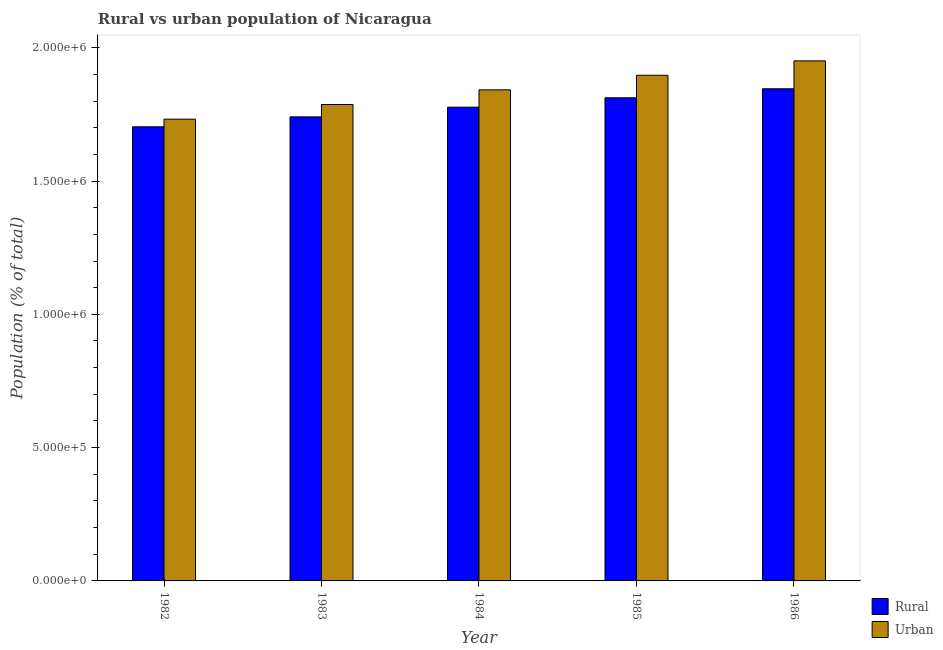Are the number of bars per tick equal to the number of legend labels?
Provide a short and direct response. Yes. How many bars are there on the 3rd tick from the left?
Keep it short and to the point. 2. How many bars are there on the 2nd tick from the right?
Make the answer very short. 2. What is the label of the 1st group of bars from the left?
Give a very brief answer. 1982. What is the urban population density in 1983?
Give a very brief answer. 1.79e+06. Across all years, what is the maximum rural population density?
Offer a very short reply. 1.85e+06. Across all years, what is the minimum urban population density?
Your response must be concise. 1.73e+06. In which year was the urban population density minimum?
Offer a very short reply. 1982. What is the total rural population density in the graph?
Your response must be concise. 8.88e+06. What is the difference between the urban population density in 1982 and that in 1983?
Ensure brevity in your answer.  -5.51e+04. What is the difference between the urban population density in 1986 and the rural population density in 1985?
Provide a succinct answer. 5.40e+04. What is the average urban population density per year?
Your answer should be very brief. 1.84e+06. What is the ratio of the rural population density in 1982 to that in 1984?
Keep it short and to the point. 0.96. What is the difference between the highest and the second highest rural population density?
Offer a terse response. 3.38e+04. What is the difference between the highest and the lowest urban population density?
Make the answer very short. 2.19e+05. Is the sum of the urban population density in 1982 and 1985 greater than the maximum rural population density across all years?
Your answer should be compact. Yes. What does the 1st bar from the left in 1984 represents?
Keep it short and to the point. Rural. What does the 2nd bar from the right in 1986 represents?
Offer a terse response. Rural. Are the values on the major ticks of Y-axis written in scientific E-notation?
Keep it short and to the point. Yes. Does the graph contain any zero values?
Keep it short and to the point. No. Does the graph contain grids?
Your response must be concise. No. How many legend labels are there?
Offer a terse response. 2. What is the title of the graph?
Ensure brevity in your answer.  Rural vs urban population of Nicaragua. What is the label or title of the Y-axis?
Offer a terse response. Population (% of total). What is the Population (% of total) of Rural in 1982?
Your answer should be compact. 1.70e+06. What is the Population (% of total) in Urban in 1982?
Offer a very short reply. 1.73e+06. What is the Population (% of total) of Rural in 1983?
Your answer should be very brief. 1.74e+06. What is the Population (% of total) in Urban in 1983?
Provide a succinct answer. 1.79e+06. What is the Population (% of total) of Rural in 1984?
Keep it short and to the point. 1.78e+06. What is the Population (% of total) of Urban in 1984?
Ensure brevity in your answer.  1.84e+06. What is the Population (% of total) of Rural in 1985?
Offer a terse response. 1.81e+06. What is the Population (% of total) of Urban in 1985?
Keep it short and to the point. 1.90e+06. What is the Population (% of total) of Rural in 1986?
Your answer should be very brief. 1.85e+06. What is the Population (% of total) of Urban in 1986?
Your answer should be very brief. 1.95e+06. Across all years, what is the maximum Population (% of total) in Rural?
Provide a succinct answer. 1.85e+06. Across all years, what is the maximum Population (% of total) in Urban?
Offer a terse response. 1.95e+06. Across all years, what is the minimum Population (% of total) of Rural?
Offer a terse response. 1.70e+06. Across all years, what is the minimum Population (% of total) of Urban?
Give a very brief answer. 1.73e+06. What is the total Population (% of total) of Rural in the graph?
Offer a terse response. 8.88e+06. What is the total Population (% of total) in Urban in the graph?
Your answer should be very brief. 9.21e+06. What is the difference between the Population (% of total) in Rural in 1982 and that in 1983?
Make the answer very short. -3.74e+04. What is the difference between the Population (% of total) of Urban in 1982 and that in 1983?
Keep it short and to the point. -5.51e+04. What is the difference between the Population (% of total) in Rural in 1982 and that in 1984?
Provide a succinct answer. -7.37e+04. What is the difference between the Population (% of total) in Urban in 1982 and that in 1984?
Provide a short and direct response. -1.10e+05. What is the difference between the Population (% of total) of Rural in 1982 and that in 1985?
Provide a succinct answer. -1.09e+05. What is the difference between the Population (% of total) of Urban in 1982 and that in 1985?
Offer a terse response. -1.65e+05. What is the difference between the Population (% of total) in Rural in 1982 and that in 1986?
Your answer should be very brief. -1.43e+05. What is the difference between the Population (% of total) in Urban in 1982 and that in 1986?
Your response must be concise. -2.19e+05. What is the difference between the Population (% of total) of Rural in 1983 and that in 1984?
Keep it short and to the point. -3.64e+04. What is the difference between the Population (% of total) of Urban in 1983 and that in 1984?
Make the answer very short. -5.49e+04. What is the difference between the Population (% of total) in Rural in 1983 and that in 1985?
Ensure brevity in your answer.  -7.16e+04. What is the difference between the Population (% of total) of Urban in 1983 and that in 1985?
Your response must be concise. -1.10e+05. What is the difference between the Population (% of total) in Rural in 1983 and that in 1986?
Provide a short and direct response. -1.05e+05. What is the difference between the Population (% of total) in Urban in 1983 and that in 1986?
Your answer should be very brief. -1.64e+05. What is the difference between the Population (% of total) in Rural in 1984 and that in 1985?
Offer a terse response. -3.52e+04. What is the difference between the Population (% of total) in Urban in 1984 and that in 1985?
Keep it short and to the point. -5.46e+04. What is the difference between the Population (% of total) in Rural in 1984 and that in 1986?
Your answer should be compact. -6.90e+04. What is the difference between the Population (% of total) of Urban in 1984 and that in 1986?
Ensure brevity in your answer.  -1.09e+05. What is the difference between the Population (% of total) in Rural in 1985 and that in 1986?
Keep it short and to the point. -3.38e+04. What is the difference between the Population (% of total) in Urban in 1985 and that in 1986?
Your answer should be very brief. -5.40e+04. What is the difference between the Population (% of total) in Rural in 1982 and the Population (% of total) in Urban in 1983?
Provide a succinct answer. -8.38e+04. What is the difference between the Population (% of total) in Rural in 1982 and the Population (% of total) in Urban in 1984?
Your answer should be very brief. -1.39e+05. What is the difference between the Population (% of total) in Rural in 1982 and the Population (% of total) in Urban in 1985?
Keep it short and to the point. -1.93e+05. What is the difference between the Population (% of total) of Rural in 1982 and the Population (% of total) of Urban in 1986?
Your answer should be compact. -2.47e+05. What is the difference between the Population (% of total) of Rural in 1983 and the Population (% of total) of Urban in 1984?
Your answer should be compact. -1.01e+05. What is the difference between the Population (% of total) in Rural in 1983 and the Population (% of total) in Urban in 1985?
Your response must be concise. -1.56e+05. What is the difference between the Population (% of total) of Rural in 1983 and the Population (% of total) of Urban in 1986?
Offer a very short reply. -2.10e+05. What is the difference between the Population (% of total) in Rural in 1984 and the Population (% of total) in Urban in 1985?
Make the answer very short. -1.20e+05. What is the difference between the Population (% of total) of Rural in 1984 and the Population (% of total) of Urban in 1986?
Ensure brevity in your answer.  -1.74e+05. What is the difference between the Population (% of total) of Rural in 1985 and the Population (% of total) of Urban in 1986?
Ensure brevity in your answer.  -1.38e+05. What is the average Population (% of total) in Rural per year?
Give a very brief answer. 1.78e+06. What is the average Population (% of total) of Urban per year?
Offer a very short reply. 1.84e+06. In the year 1982, what is the difference between the Population (% of total) in Rural and Population (% of total) in Urban?
Provide a short and direct response. -2.87e+04. In the year 1983, what is the difference between the Population (% of total) in Rural and Population (% of total) in Urban?
Offer a terse response. -4.64e+04. In the year 1984, what is the difference between the Population (% of total) of Rural and Population (% of total) of Urban?
Give a very brief answer. -6.50e+04. In the year 1985, what is the difference between the Population (% of total) in Rural and Population (% of total) in Urban?
Make the answer very short. -8.44e+04. In the year 1986, what is the difference between the Population (% of total) in Rural and Population (% of total) in Urban?
Offer a very short reply. -1.05e+05. What is the ratio of the Population (% of total) of Rural in 1982 to that in 1983?
Ensure brevity in your answer.  0.98. What is the ratio of the Population (% of total) in Urban in 1982 to that in 1983?
Offer a very short reply. 0.97. What is the ratio of the Population (% of total) in Rural in 1982 to that in 1984?
Offer a terse response. 0.96. What is the ratio of the Population (% of total) in Urban in 1982 to that in 1984?
Offer a very short reply. 0.94. What is the ratio of the Population (% of total) in Rural in 1982 to that in 1985?
Give a very brief answer. 0.94. What is the ratio of the Population (% of total) in Urban in 1982 to that in 1985?
Ensure brevity in your answer.  0.91. What is the ratio of the Population (% of total) of Rural in 1982 to that in 1986?
Give a very brief answer. 0.92. What is the ratio of the Population (% of total) of Urban in 1982 to that in 1986?
Ensure brevity in your answer.  0.89. What is the ratio of the Population (% of total) in Rural in 1983 to that in 1984?
Your answer should be very brief. 0.98. What is the ratio of the Population (% of total) in Urban in 1983 to that in 1984?
Give a very brief answer. 0.97. What is the ratio of the Population (% of total) of Rural in 1983 to that in 1985?
Provide a succinct answer. 0.96. What is the ratio of the Population (% of total) in Urban in 1983 to that in 1985?
Your response must be concise. 0.94. What is the ratio of the Population (% of total) in Rural in 1983 to that in 1986?
Keep it short and to the point. 0.94. What is the ratio of the Population (% of total) of Urban in 1983 to that in 1986?
Your answer should be compact. 0.92. What is the ratio of the Population (% of total) in Rural in 1984 to that in 1985?
Provide a succinct answer. 0.98. What is the ratio of the Population (% of total) in Urban in 1984 to that in 1985?
Give a very brief answer. 0.97. What is the ratio of the Population (% of total) in Rural in 1984 to that in 1986?
Give a very brief answer. 0.96. What is the ratio of the Population (% of total) in Urban in 1984 to that in 1986?
Offer a very short reply. 0.94. What is the ratio of the Population (% of total) of Rural in 1985 to that in 1986?
Provide a short and direct response. 0.98. What is the ratio of the Population (% of total) of Urban in 1985 to that in 1986?
Provide a short and direct response. 0.97. What is the difference between the highest and the second highest Population (% of total) of Rural?
Your response must be concise. 3.38e+04. What is the difference between the highest and the second highest Population (% of total) in Urban?
Give a very brief answer. 5.40e+04. What is the difference between the highest and the lowest Population (% of total) in Rural?
Provide a short and direct response. 1.43e+05. What is the difference between the highest and the lowest Population (% of total) in Urban?
Your answer should be compact. 2.19e+05. 